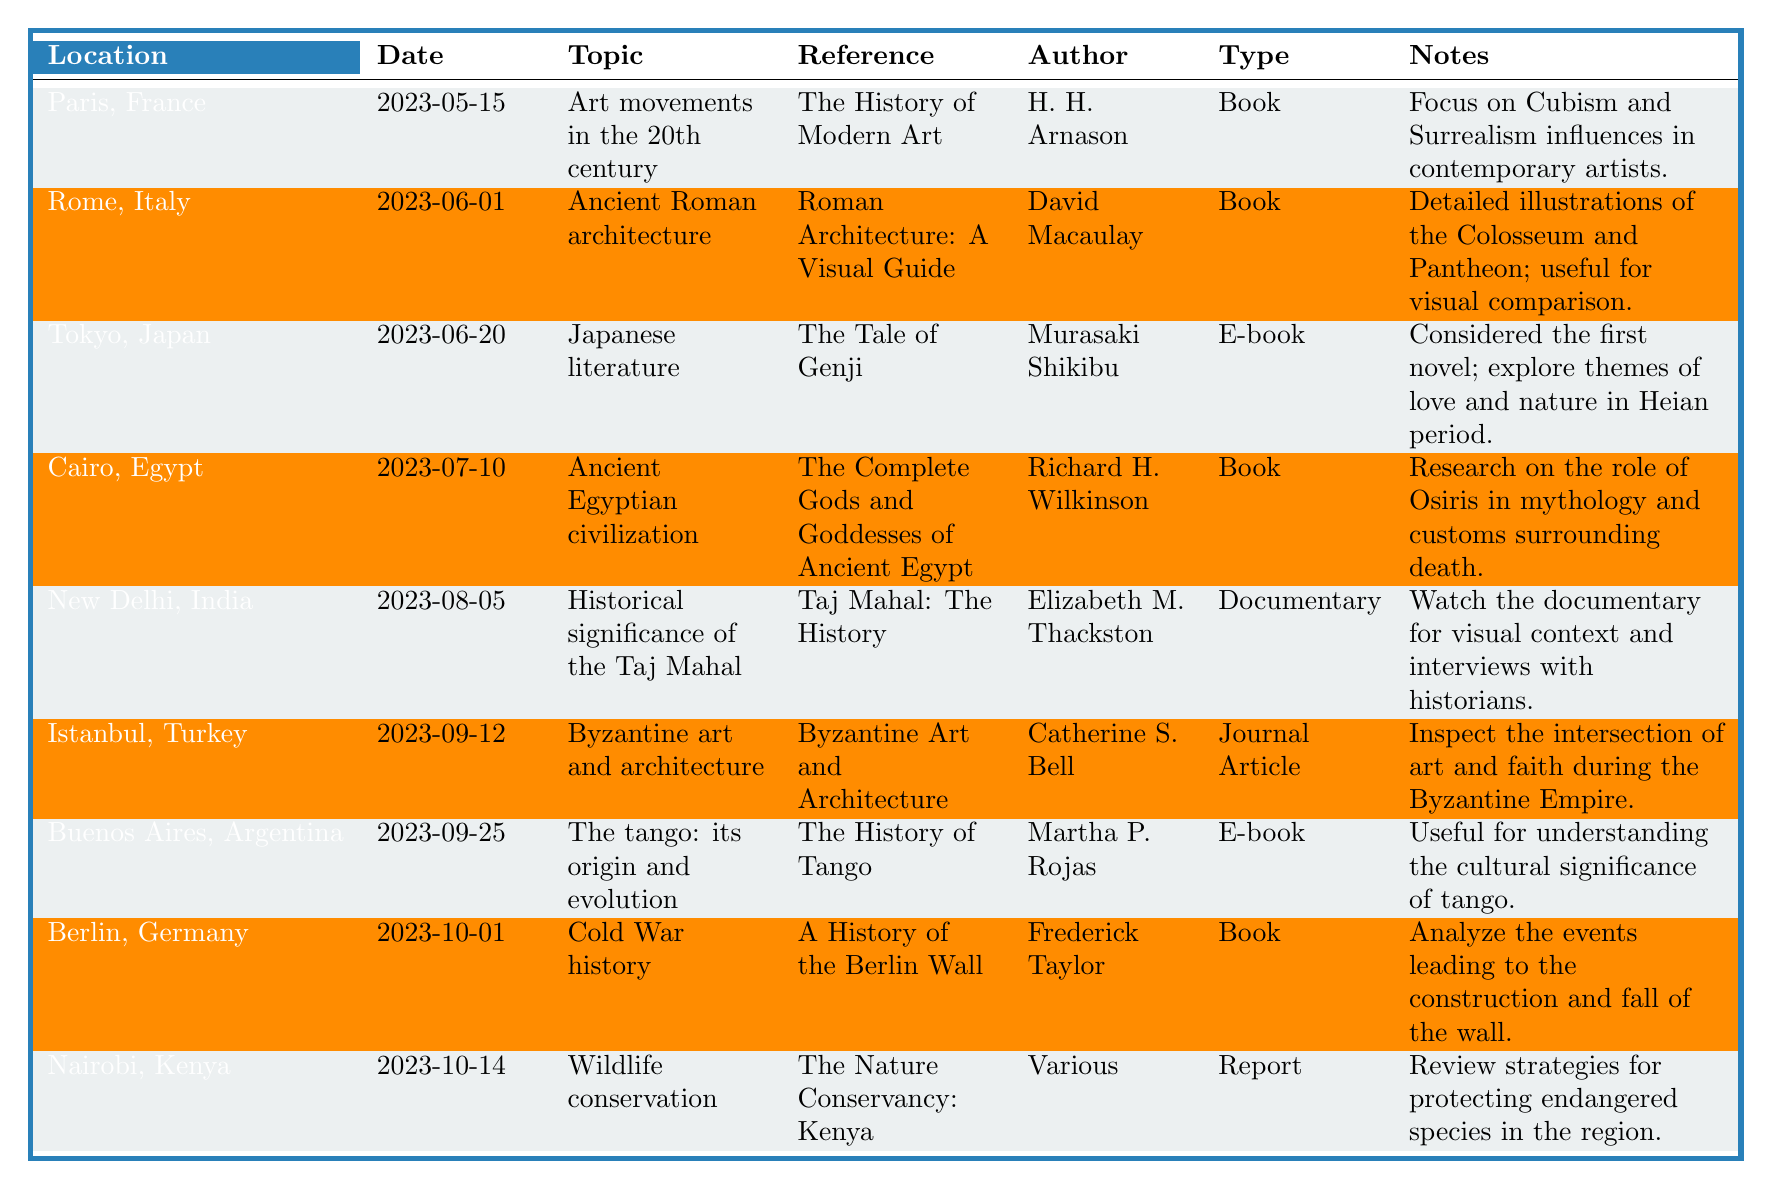What location was the research on wildlife conservation collected? The table specifies that the research on wildlife conservation was collected in Nairobi, Kenya.
Answer: Nairobi, Kenya Who is the author of "The History of Modern Art"? According to the table, "The History of Modern Art" is authored by H. H. Arnason.
Answer: H. H. Arnason What type of material was used for the research on the historical significance of the Taj Mahal? The table indicates that the research on the historical significance of the Taj Mahal was conducted using a documentary.
Answer: Documentary How many different research topics were noted in this table? By counting each unique research topic listed in the table, we find there are 9 distinct topics: Art movements, Ancient Roman architecture, Japanese literature, Ancient Egyptian civilization, Taj Mahal significance, Byzantine art, Tango origins, Cold War history, and Wildlife conservation.
Answer: 9 Which reference has a focus on the role of Osiris in mythology? The table shows that "The Complete Gods and Goddesses of Ancient Egypt" by Richard H. Wilkinson focuses on the role of Osiris in mythology.
Answer: The Complete Gods and Goddesses of Ancient Egypt Is there a reference related to Cold War history? Yes, the table has a reference titled "A History of the Berlin Wall" by Frederick Taylor, which is related to Cold War history.
Answer: Yes What is the most recent date collected for research, and in which location? The most recent date collected is 2023-10-14, and it is associated with research in Nairobi, Kenya.
Answer: 2023-10-14, Nairobi, Kenya Which research topic refers to a literary work considered the first novel? The table notes that "The Tale of Genji" under the research topic of Japanese literature refers to a literary work considered the first novel.
Answer: Japanese literature Which two locations focus on visual aspects within their research materials? The research collected from Rome, Italy, on Ancient Roman architecture, and New Delhi, India, on the Taj Mahal include visual aspects, as indicated by the type of materials and notes in the table.
Answer: Rome, Italy and New Delhi, India What type of material was most frequently used for this research collection? By analyzing the types of materials listed, we find that the most frequently used type is the book, with 5 instances when compared to other types of materials.
Answer: Book 